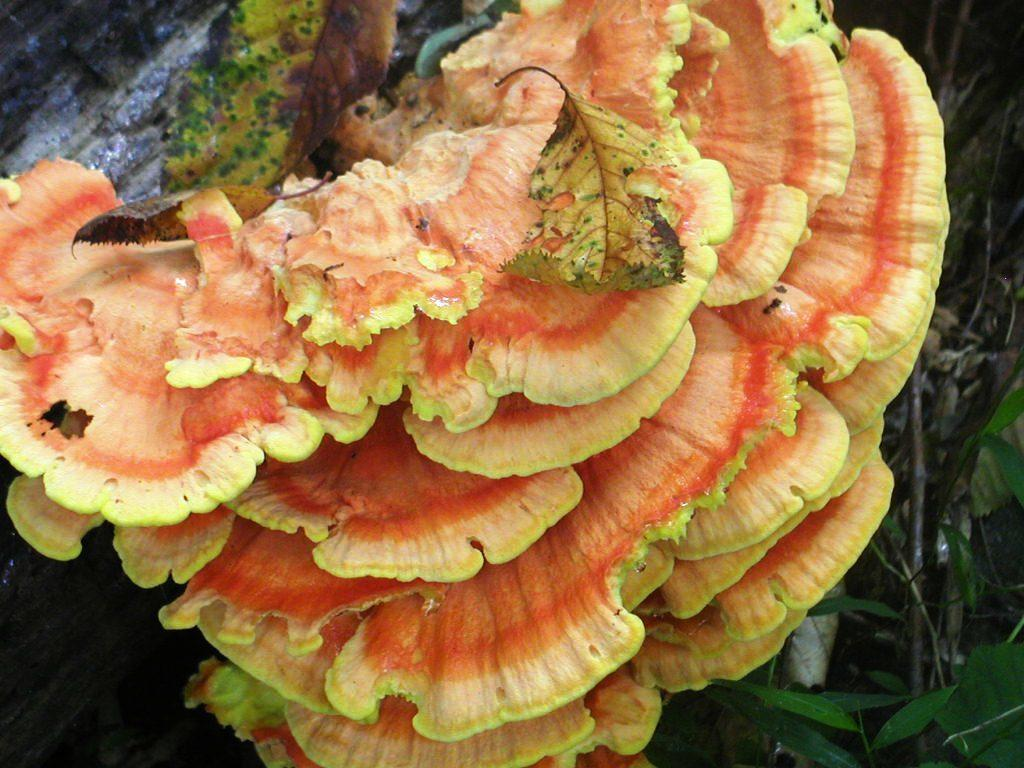What is the color of the mushroom in the picture? The mushroom in the picture is yellow and pink. What can be found beside the mushroom? There are leaves beside the mushroom. What reason does the mushroom give for being in the picture? Mushrooms do not have the ability to give reasons, as they are inanimate objects. 